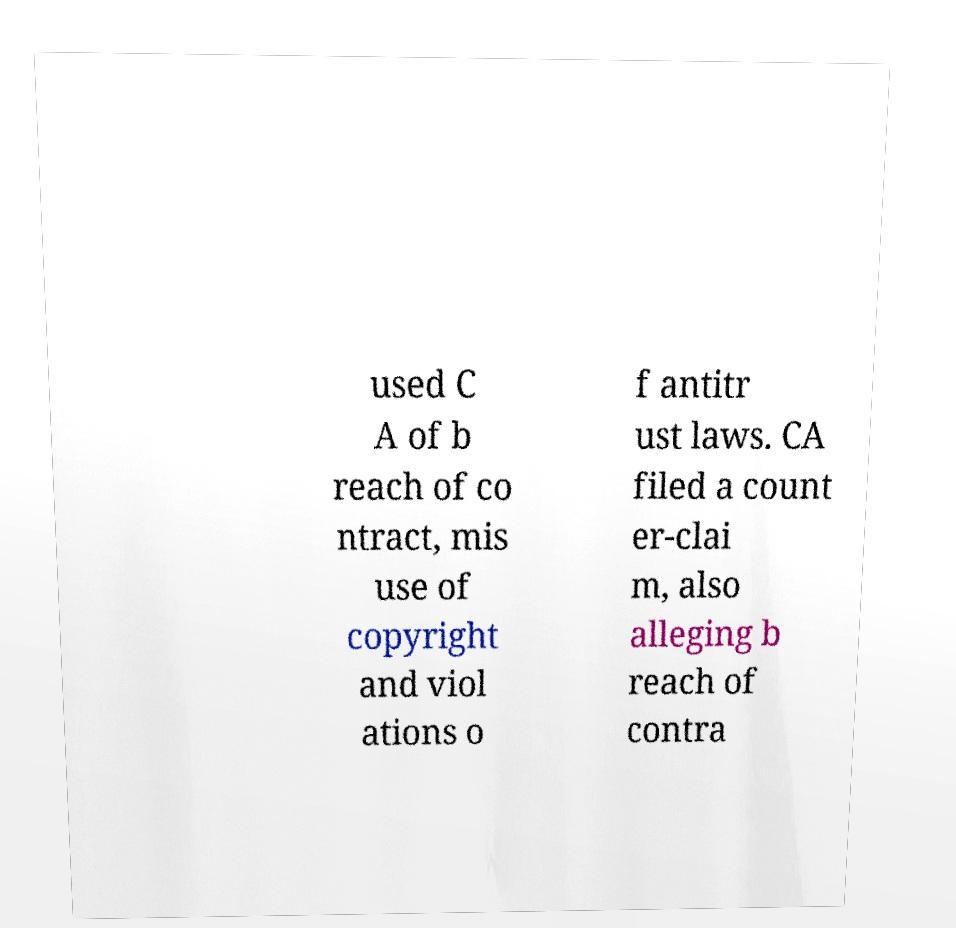For documentation purposes, I need the text within this image transcribed. Could you provide that? used C A of b reach of co ntract, mis use of copyright and viol ations o f antitr ust laws. CA filed a count er-clai m, also alleging b reach of contra 